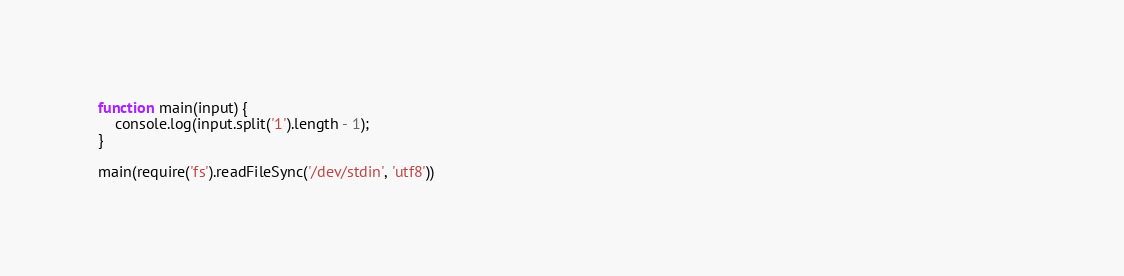<code> <loc_0><loc_0><loc_500><loc_500><_JavaScript_>function main(input) {                                                                                                                                                                                 
    console.log(input.split('1').length - 1);                                                                                                                                                          
}                                                                                                                                                                                                      
                                                                                                                                                                                                       
main(require('fs').readFileSync('/dev/stdin', 'utf8')) </code> 